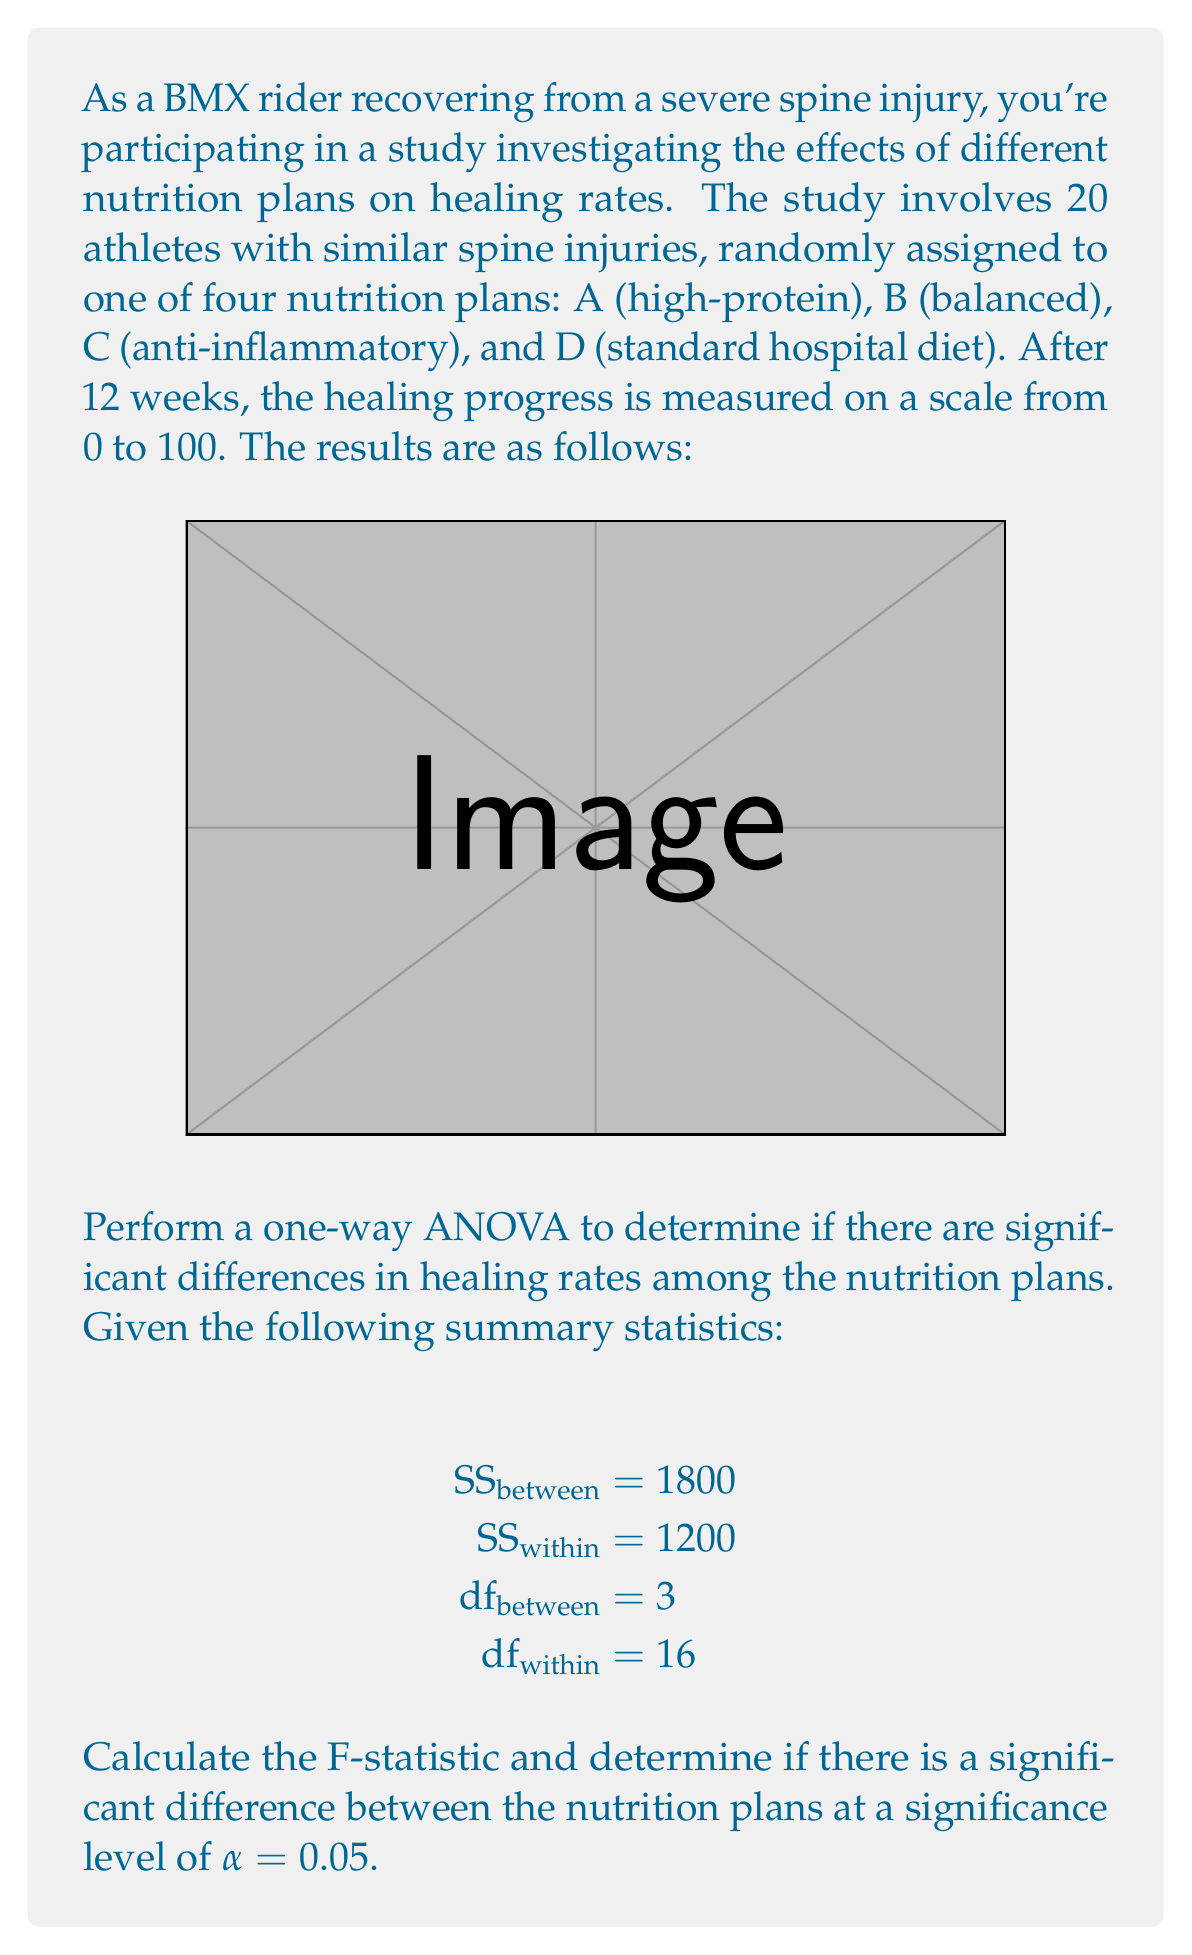Can you solve this math problem? To perform a one-way ANOVA and calculate the F-statistic, we'll follow these steps:

1. Calculate the Mean Square Between (MSB) and Mean Square Within (MSW):

   $$\text{MSB} = \frac{\text{SS}_{\text{between}}}{\text{df}_{\text{between}}} = \frac{1800}{3} = 600$$
   
   $$\text{MSW} = \frac{\text{SS}_{\text{within}}}{\text{df}_{\text{within}}} = \frac{1200}{16} = 75$$

2. Calculate the F-statistic:

   $$F = \frac{\text{MSB}}{\text{MSW}} = \frac{600}{75} = 8$$

3. Determine the critical F-value:
   With α = 0.05, df_between = 3, and df_within = 16, we can look up the critical F-value in an F-distribution table or use a calculator. The critical F-value is approximately 3.24.

4. Compare the calculated F-statistic to the critical F-value:
   Since our calculated F-statistic (8) is greater than the critical F-value (3.24), we reject the null hypothesis.

5. Interpret the results:
   There is a statistically significant difference in healing rates among the different nutrition plans at the 0.05 significance level.

This analysis suggests that the choice of nutrition plan has a significant effect on the healing rate for spine injuries in BMX riders.
Answer: F = 8; Significant difference (p < 0.05) 